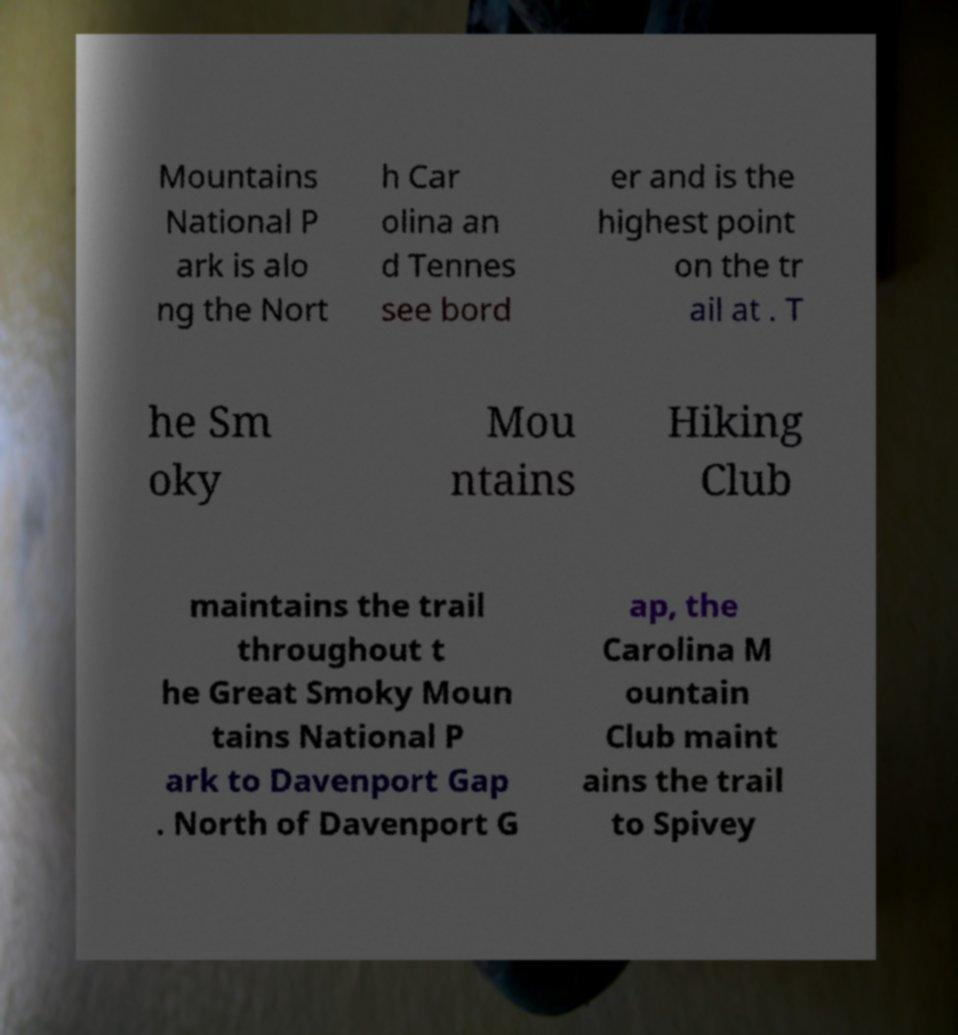Could you extract and type out the text from this image? Mountains National P ark is alo ng the Nort h Car olina an d Tennes see bord er and is the highest point on the tr ail at . T he Sm oky Mou ntains Hiking Club maintains the trail throughout t he Great Smoky Moun tains National P ark to Davenport Gap . North of Davenport G ap, the Carolina M ountain Club maint ains the trail to Spivey 